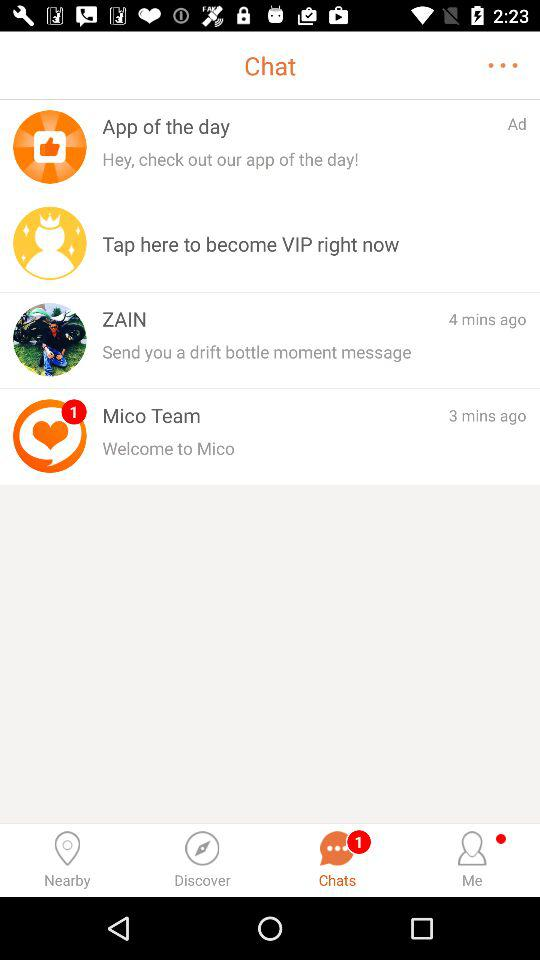How many messages have I received?
Answer the question using a single word or phrase. 2 